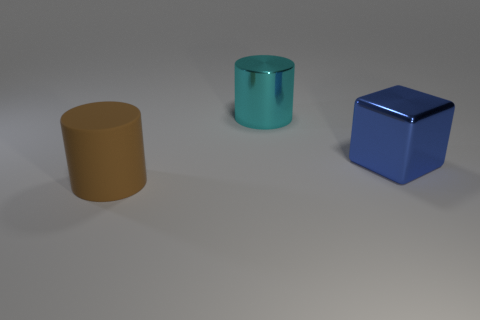Is there any other thing that has the same material as the brown object?
Provide a short and direct response. No. What is the big cube made of?
Your answer should be compact. Metal. Is the number of large blocks that are left of the cube greater than the number of large brown rubber cylinders that are in front of the big brown object?
Give a very brief answer. No. What size is the cyan shiny object that is the same shape as the brown object?
Offer a very short reply. Large. What number of cylinders are either big rubber objects or small purple rubber things?
Provide a short and direct response. 1. Are there fewer big brown rubber cylinders that are in front of the matte thing than large cyan shiny cylinders behind the cyan metal thing?
Make the answer very short. No. What number of objects are either things on the left side of the shiny cylinder or tiny brown spheres?
Provide a succinct answer. 1. What is the shape of the large thing left of the shiny object that is behind the cube?
Your answer should be compact. Cylinder. Are there any blue blocks that have the same size as the rubber thing?
Provide a succinct answer. Yes. Is the number of blocks greater than the number of big gray cylinders?
Make the answer very short. Yes. 